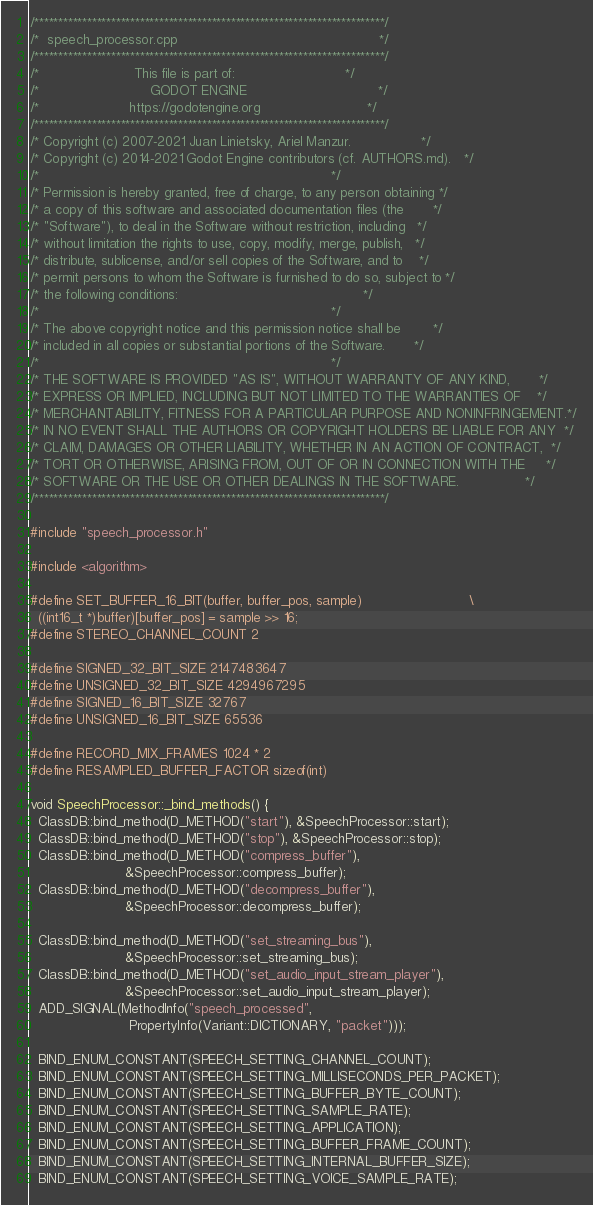Convert code to text. <code><loc_0><loc_0><loc_500><loc_500><_C++_>/*************************************************************************/
/*  speech_processor.cpp                                                 */
/*************************************************************************/
/*                       This file is part of:                           */
/*                           GODOT ENGINE                                */
/*                      https://godotengine.org                          */
/*************************************************************************/
/* Copyright (c) 2007-2021 Juan Linietsky, Ariel Manzur.                 */
/* Copyright (c) 2014-2021 Godot Engine contributors (cf. AUTHORS.md).   */
/*                                                                       */
/* Permission is hereby granted, free of charge, to any person obtaining */
/* a copy of this software and associated documentation files (the       */
/* "Software"), to deal in the Software without restriction, including   */
/* without limitation the rights to use, copy, modify, merge, publish,   */
/* distribute, sublicense, and/or sell copies of the Software, and to    */
/* permit persons to whom the Software is furnished to do so, subject to */
/* the following conditions:                                             */
/*                                                                       */
/* The above copyright notice and this permission notice shall be        */
/* included in all copies or substantial portions of the Software.       */
/*                                                                       */
/* THE SOFTWARE IS PROVIDED "AS IS", WITHOUT WARRANTY OF ANY KIND,       */
/* EXPRESS OR IMPLIED, INCLUDING BUT NOT LIMITED TO THE WARRANTIES OF    */
/* MERCHANTABILITY, FITNESS FOR A PARTICULAR PURPOSE AND NONINFRINGEMENT.*/
/* IN NO EVENT SHALL THE AUTHORS OR COPYRIGHT HOLDERS BE LIABLE FOR ANY  */
/* CLAIM, DAMAGES OR OTHER LIABILITY, WHETHER IN AN ACTION OF CONTRACT,  */
/* TORT OR OTHERWISE, ARISING FROM, OUT OF OR IN CONNECTION WITH THE     */
/* SOFTWARE OR THE USE OR OTHER DEALINGS IN THE SOFTWARE.                */
/*************************************************************************/

#include "speech_processor.h"

#include <algorithm>

#define SET_BUFFER_16_BIT(buffer, buffer_pos, sample)                          \
  ((int16_t *)buffer)[buffer_pos] = sample >> 16;
#define STEREO_CHANNEL_COUNT 2

#define SIGNED_32_BIT_SIZE 2147483647
#define UNSIGNED_32_BIT_SIZE 4294967295
#define SIGNED_16_BIT_SIZE 32767
#define UNSIGNED_16_BIT_SIZE 65536

#define RECORD_MIX_FRAMES 1024 * 2
#define RESAMPLED_BUFFER_FACTOR sizeof(int)

void SpeechProcessor::_bind_methods() {
  ClassDB::bind_method(D_METHOD("start"), &SpeechProcessor::start);
  ClassDB::bind_method(D_METHOD("stop"), &SpeechProcessor::stop);
  ClassDB::bind_method(D_METHOD("compress_buffer"),
                       &SpeechProcessor::compress_buffer);
  ClassDB::bind_method(D_METHOD("decompress_buffer"),
                       &SpeechProcessor::decompress_buffer);

  ClassDB::bind_method(D_METHOD("set_streaming_bus"),
                       &SpeechProcessor::set_streaming_bus);
  ClassDB::bind_method(D_METHOD("set_audio_input_stream_player"),
                       &SpeechProcessor::set_audio_input_stream_player);
  ADD_SIGNAL(MethodInfo("speech_processed",
                        PropertyInfo(Variant::DICTIONARY, "packet")));

  BIND_ENUM_CONSTANT(SPEECH_SETTING_CHANNEL_COUNT);
  BIND_ENUM_CONSTANT(SPEECH_SETTING_MILLISECONDS_PER_PACKET);
  BIND_ENUM_CONSTANT(SPEECH_SETTING_BUFFER_BYTE_COUNT);
  BIND_ENUM_CONSTANT(SPEECH_SETTING_SAMPLE_RATE);
  BIND_ENUM_CONSTANT(SPEECH_SETTING_APPLICATION);
  BIND_ENUM_CONSTANT(SPEECH_SETTING_BUFFER_FRAME_COUNT);
  BIND_ENUM_CONSTANT(SPEECH_SETTING_INTERNAL_BUFFER_SIZE);
  BIND_ENUM_CONSTANT(SPEECH_SETTING_VOICE_SAMPLE_RATE);</code> 